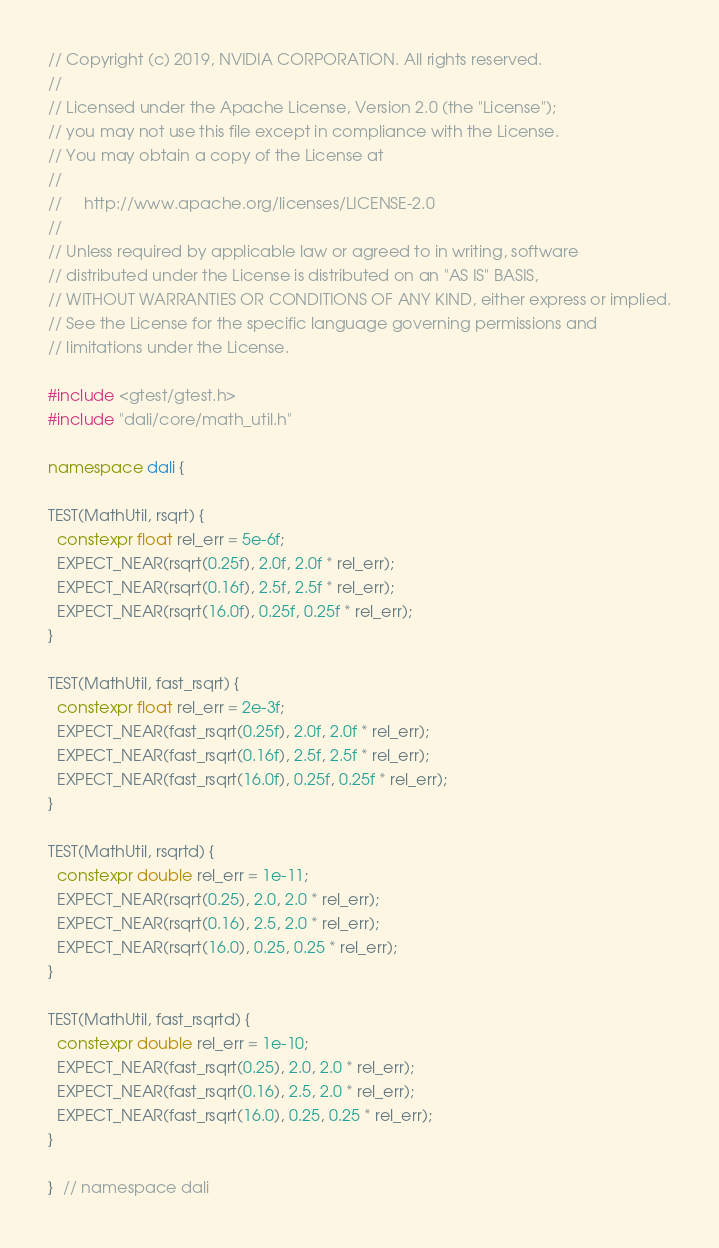<code> <loc_0><loc_0><loc_500><loc_500><_C++_>// Copyright (c) 2019, NVIDIA CORPORATION. All rights reserved.
//
// Licensed under the Apache License, Version 2.0 (the "License");
// you may not use this file except in compliance with the License.
// You may obtain a copy of the License at
//
//     http://www.apache.org/licenses/LICENSE-2.0
//
// Unless required by applicable law or agreed to in writing, software
// distributed under the License is distributed on an "AS IS" BASIS,
// WITHOUT WARRANTIES OR CONDITIONS OF ANY KIND, either express or implied.
// See the License for the specific language governing permissions and
// limitations under the License.

#include <gtest/gtest.h>
#include "dali/core/math_util.h"

namespace dali {

TEST(MathUtil, rsqrt) {
  constexpr float rel_err = 5e-6f;
  EXPECT_NEAR(rsqrt(0.25f), 2.0f, 2.0f * rel_err);
  EXPECT_NEAR(rsqrt(0.16f), 2.5f, 2.5f * rel_err);
  EXPECT_NEAR(rsqrt(16.0f), 0.25f, 0.25f * rel_err);
}

TEST(MathUtil, fast_rsqrt) {
  constexpr float rel_err = 2e-3f;
  EXPECT_NEAR(fast_rsqrt(0.25f), 2.0f, 2.0f * rel_err);
  EXPECT_NEAR(fast_rsqrt(0.16f), 2.5f, 2.5f * rel_err);
  EXPECT_NEAR(fast_rsqrt(16.0f), 0.25f, 0.25f * rel_err);
}

TEST(MathUtil, rsqrtd) {
  constexpr double rel_err = 1e-11;
  EXPECT_NEAR(rsqrt(0.25), 2.0, 2.0 * rel_err);
  EXPECT_NEAR(rsqrt(0.16), 2.5, 2.0 * rel_err);
  EXPECT_NEAR(rsqrt(16.0), 0.25, 0.25 * rel_err);
}

TEST(MathUtil, fast_rsqrtd) {
  constexpr double rel_err = 1e-10;
  EXPECT_NEAR(fast_rsqrt(0.25), 2.0, 2.0 * rel_err);
  EXPECT_NEAR(fast_rsqrt(0.16), 2.5, 2.0 * rel_err);
  EXPECT_NEAR(fast_rsqrt(16.0), 0.25, 0.25 * rel_err);
}

}  // namespace dali
</code> 